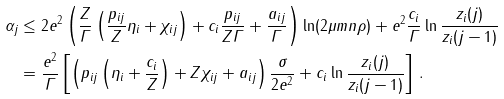<formula> <loc_0><loc_0><loc_500><loc_500>\alpha _ { j } & \leq 2 e ^ { 2 } \left ( \frac { Z } { \varGamma } \left ( \frac { p _ { i j } } { Z } \eta _ { i } + \chi _ { i j } \right ) + c _ { i } \frac { p _ { i j } } { Z \varGamma } + \frac { a _ { i j } } { \varGamma } \right ) \ln ( 2 \mu m n \rho ) + e ^ { 2 } \frac { c _ { i } } { \varGamma } \ln \frac { z _ { i } ( j ) } { z _ { i } ( j - 1 ) } \\ & = \frac { e ^ { 2 } } { \varGamma } \left [ \left ( p _ { i j } \left ( \eta _ { i } + \frac { c _ { i } } { Z } \right ) + Z \chi _ { i j } + a _ { i j } \right ) \frac { \sigma } { 2 e ^ { 2 } } + c _ { i } \ln \frac { z _ { i } ( j ) } { z _ { i } ( j - 1 ) } \right ] \, .</formula> 